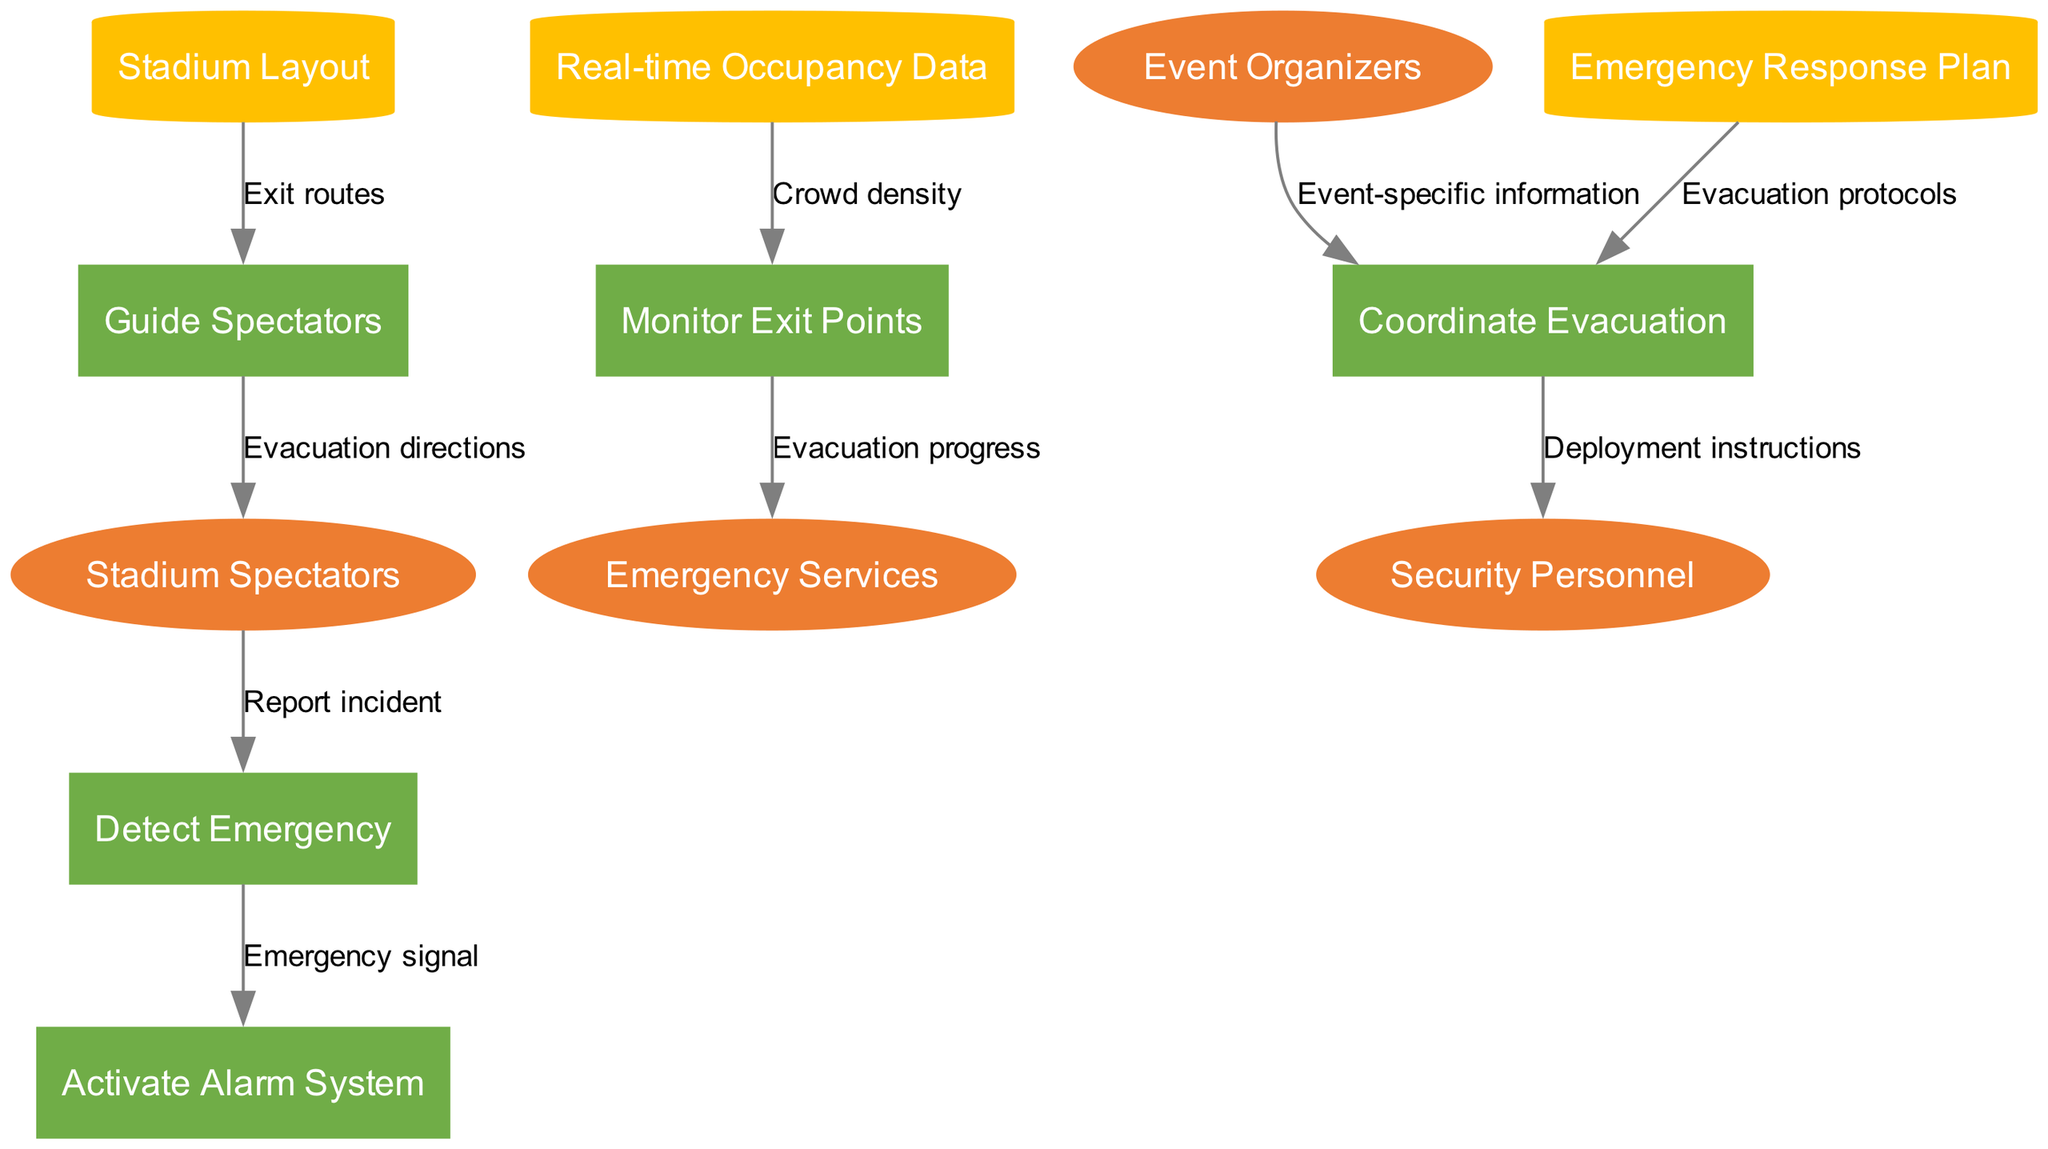What is the number of external entities in the diagram? The diagram lists four external entities: Stadium Spectators, Emergency Services, Security Personnel, and Event Organizers. Counting these entities gives us a total of four.
Answer: 4 Which process receives the emergency signal? The emergency signal flows from "Detect Emergency" to "Activate Alarm System"; therefore, "Activate Alarm System" is the process that receives the emergency signal.
Answer: Activate Alarm System What is the label of the data flow from "Emergency Response Plan" to "Coordinate Evacuation"? The data flow from "Emergency Response Plan" to "Coordinate Evacuation" is labeled "Evacuation protocols"; thus, this is the information conveyed in this flow.
Answer: Evacuation protocols Who provides event-specific information to the "Coordinate Evacuation" process? The external entity "Event Organizers" provides event-specific information, as denoted by the data flow between them and the "Coordinate Evacuation" process.
Answer: Event Organizers What type of node represents the "Stadium Layout" in the diagram? The "Stadium Layout" is represented as a data store in the diagram, shown as a cylinder shape which is characteristic of data stores in Data Flow Diagrams.
Answer: data store Which external entity reports an incident to the "Detect Emergency" process? The diagram indicates that "Stadium Spectators" are responsible for reporting incidents to the "Detect Emergency" process, as shown in the flow direction.
Answer: Stadium Spectators How many processes are there in total? There are five processes in the diagram: Detect Emergency, Activate Alarm System, Coordinate Evacuation, Guide Spectators, and Monitor Exit Points. Counting these processes shows a total of five.
Answer: 5 What is the data flow from "Monitor Exit Points" to "Emergency Services" labeled as? The data flow from "Monitor Exit Points" to "Emergency Services" is labeled "Evacuation progress" according to the diagram.
Answer: Evacuation progress Which component provides crowd density data? The component labeled "Real-time Occupancy Data" provides crowd density data, feeding this information into the "Monitor Exit Points" process.
Answer: Real-time Occupancy Data 